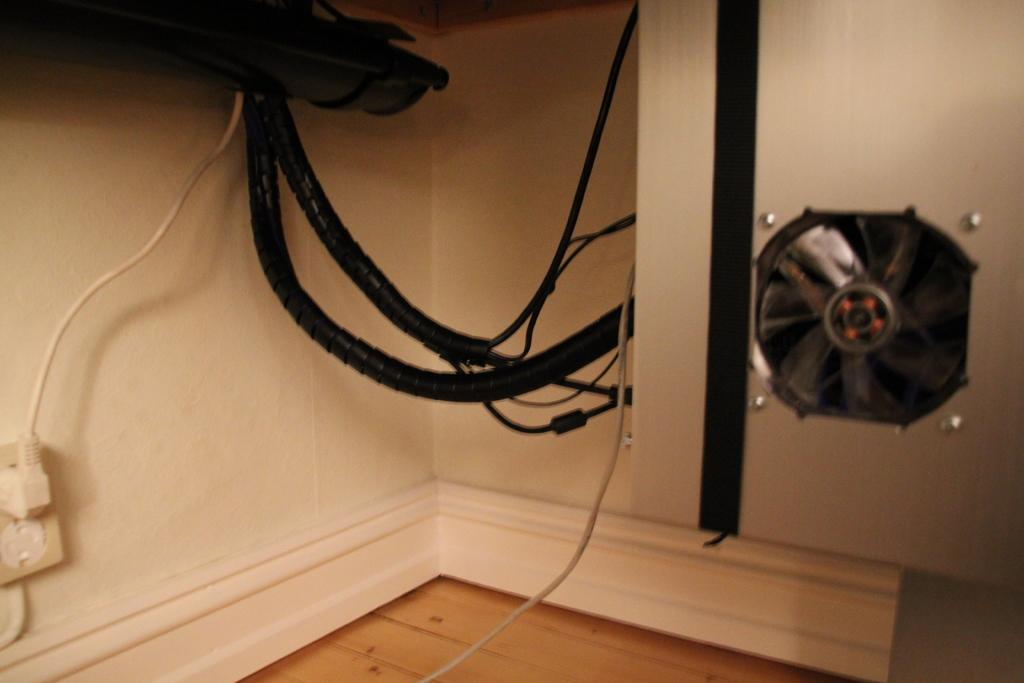What type of device is located in the right corner of the image? There is a small fan in the right corner of the image. Are there any other objects near the fan in the image? Yes, there are cables beside the fan in the image. What type of wood can be seen in the image? There is no wood visible in the image. What are the hands of the person in the image doing? There is no person present in the image, so their hands cannot be observed. 